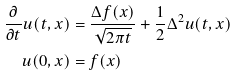Convert formula to latex. <formula><loc_0><loc_0><loc_500><loc_500>\frac { \partial } { \partial t } u ( t , x ) & = \frac { \Delta f ( x ) } { \sqrt { 2 \pi t } } + \frac { 1 } { 2 } \Delta ^ { 2 } u ( t , x ) \\ u ( 0 , x ) & = f ( x )</formula> 